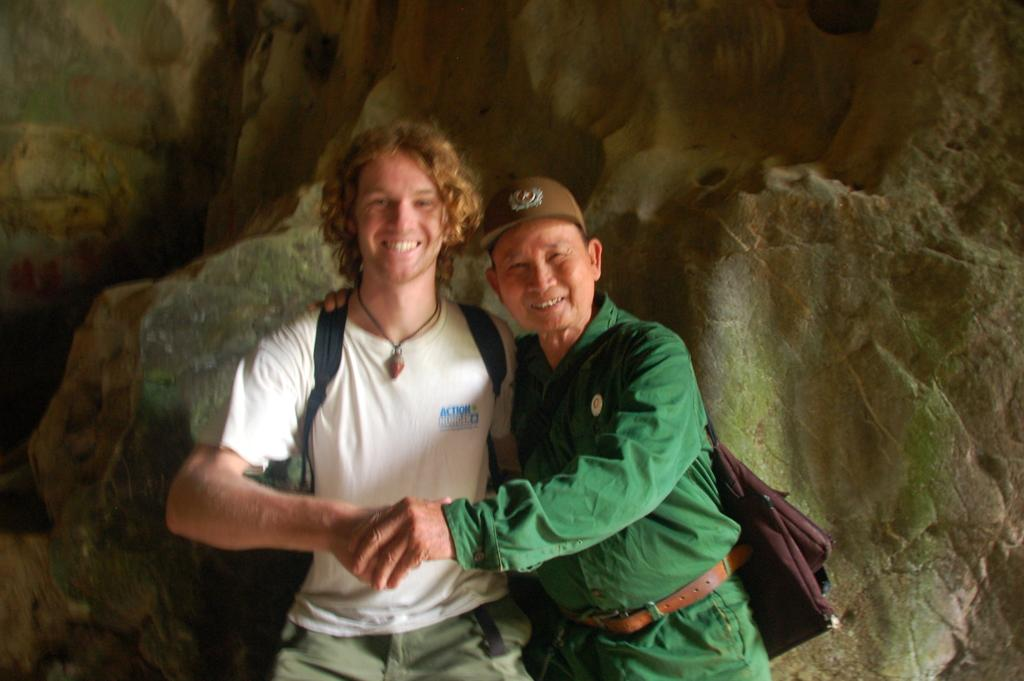How many people are in the image? There are people in the image, but the exact number is not specified. What are the people wearing? The people are wearing bags. Can you describe any additional accessories worn by the people? One person is wearing a cap. What can be seen in the background of the image? There are rocks in the background of the image. How do the people in the image sort the rocks? There is no indication in the image that the people are sorting rocks, so it cannot be determined from the picture. 